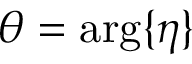Convert formula to latex. <formula><loc_0><loc_0><loc_500><loc_500>\theta = \arg \{ \eta \}</formula> 